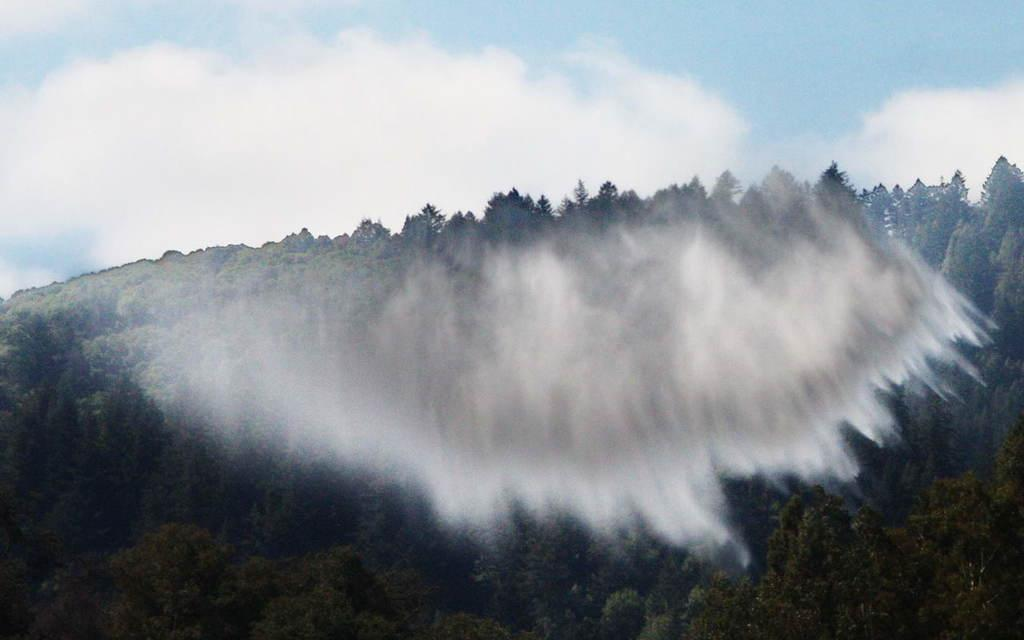What geographical feature is the main subject of the image? There is a mountain in the image. What can be seen on the mountain? The mountain is covered with trees and plants. What atmospheric condition is present in the image? There is smog in the image. What is visible in the sky in the image? Clouds are visible in the sky. What type of fish can be seen swimming in the smog in the image? There are no fish present in the image, and fish cannot swim in smog. 